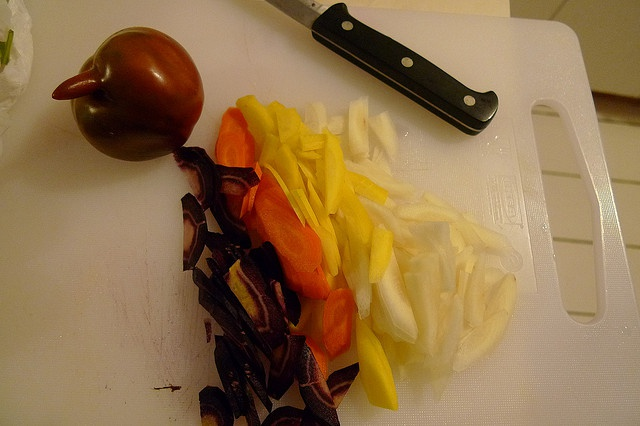Describe the objects in this image and their specific colors. I can see carrot in olive, brown, maroon, and red tones and knife in olive, black, maroon, and tan tones in this image. 